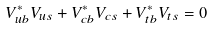<formula> <loc_0><loc_0><loc_500><loc_500>V ^ { * } _ { u b } V _ { u s } + V ^ { * } _ { c b } V _ { c s } + V ^ { * } _ { t b } V _ { t s } = 0</formula> 